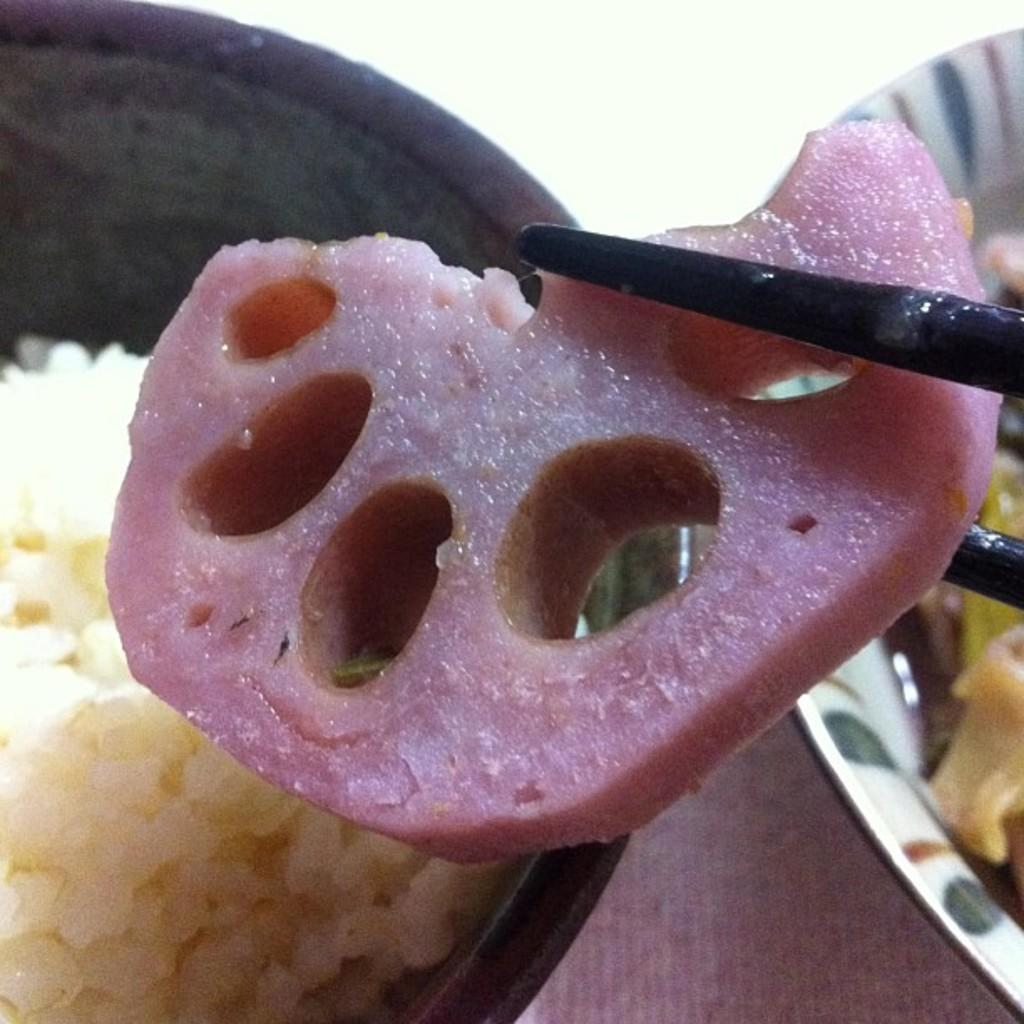What type of containers are visible in the image? There are bowls containing food in the image. What utensils are used to eat the food in the image? There are chopsticks holding food in the image. How much money is being used to purchase the food in the image? There is no indication of money or a transaction in the image; it only shows bowls containing food and chopsticks holding food. 